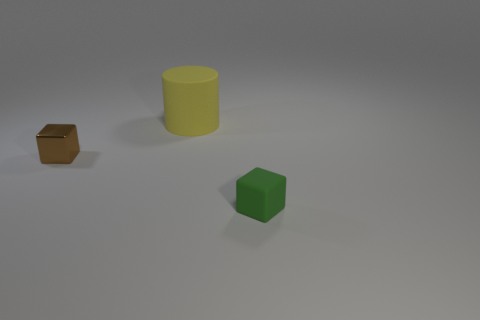Are there any other things that are the same size as the yellow thing?
Give a very brief answer. No. What number of tiny objects are either yellow things or blocks?
Your answer should be very brief. 2. Is the small thing left of the green block made of the same material as the small block that is right of the tiny brown cube?
Your response must be concise. No. Are there any green objects?
Offer a very short reply. Yes. Is the number of blocks left of the brown shiny block greater than the number of large yellow matte cylinders on the right side of the big yellow matte cylinder?
Give a very brief answer. No. What material is the other object that is the same shape as the tiny rubber object?
Give a very brief answer. Metal. Does the rubber thing in front of the brown metal thing have the same color as the small thing that is to the left of the cylinder?
Offer a terse response. No. There is a big rubber object; what shape is it?
Give a very brief answer. Cylinder. Is the number of yellow objects behind the shiny block greater than the number of shiny cubes?
Keep it short and to the point. No. There is a small object that is in front of the metallic block; what shape is it?
Keep it short and to the point. Cube. 